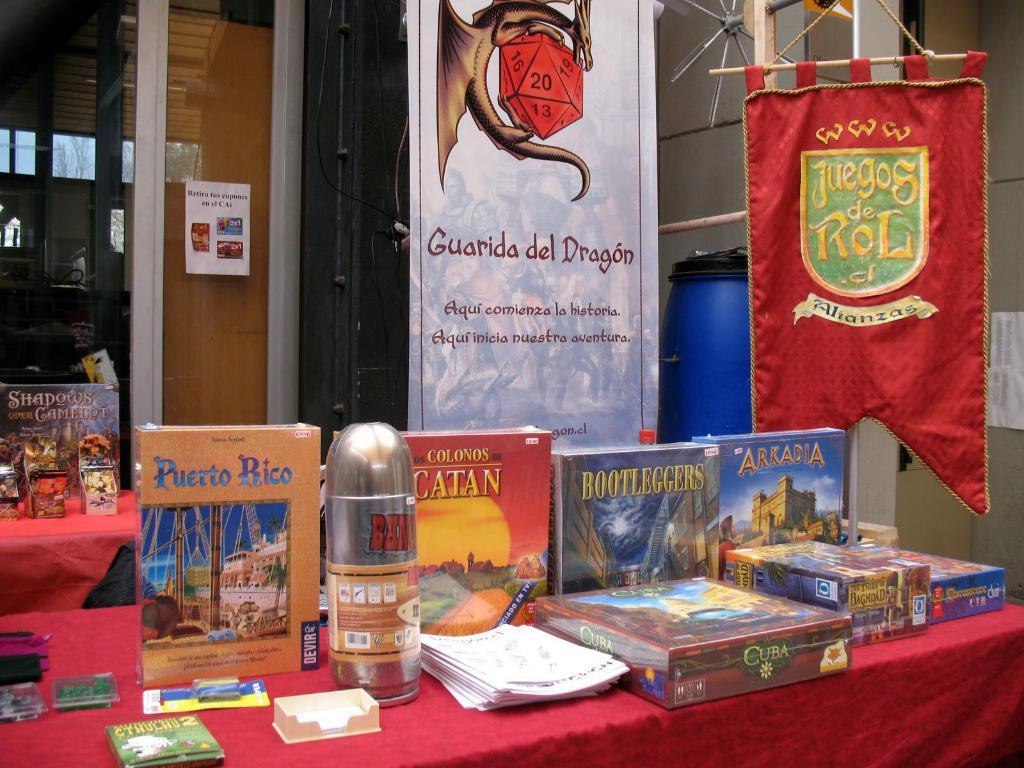<image>
Offer a succinct explanation of the picture presented. Several books are on a table including one titled Puerto Rico. 